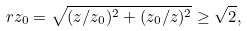Convert formula to latex. <formula><loc_0><loc_0><loc_500><loc_500>r z _ { 0 } = \sqrt { ( z / z _ { 0 } ) ^ { 2 } + ( z _ { 0 } / z ) ^ { 2 } } \geq \sqrt { 2 } ,</formula> 